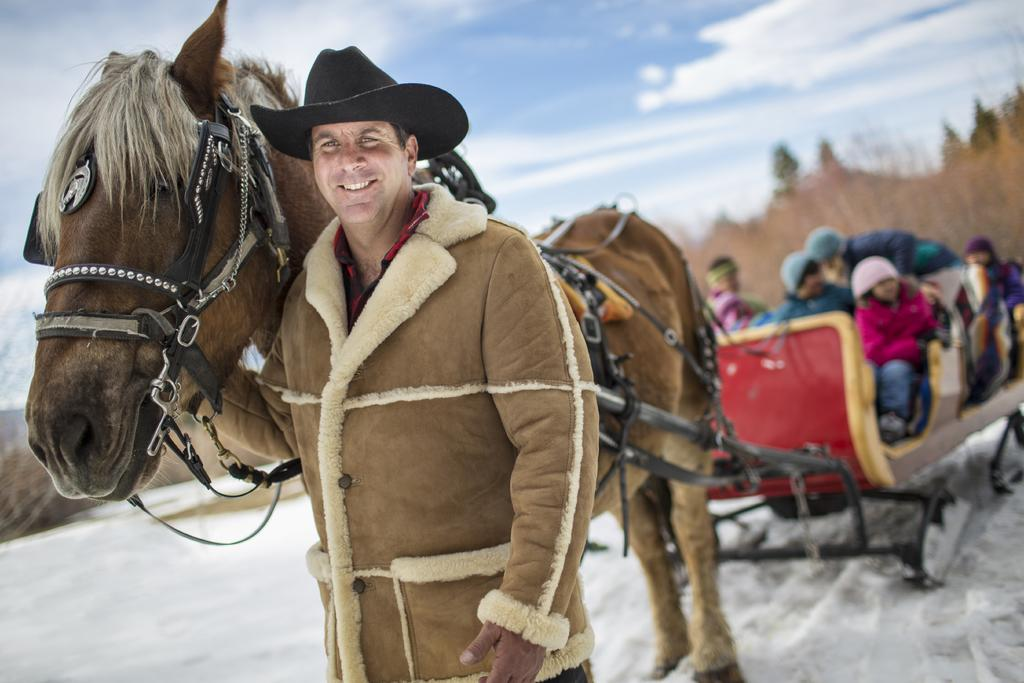What is the main subject of the image? The main subject of the image is a man. What is the man wearing in the image? The man is wearing a coat and a hat in the image. What is the man's facial expression in the image? The man is smiling in the image. What is the man holding in the image? The man is holding a horse in the image. What can be seen in the background of the image? There are people sitting in the background of the image. How is the sky depicted in the image? The sky is clear in the backdrop of the image. What type of degree is the man holding in the image? There is no degree present in the image; the man is holding a horse. Is there a cave visible in the image? No, there is no cave present in the image. 